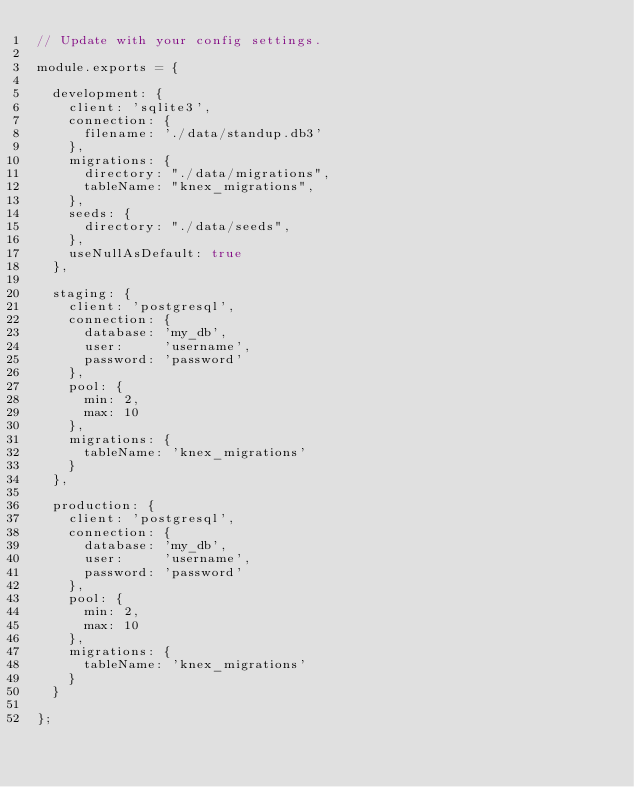Convert code to text. <code><loc_0><loc_0><loc_500><loc_500><_JavaScript_>// Update with your config settings.

module.exports = {

  development: {
    client: 'sqlite3',
    connection: {
      filename: './data/standup.db3'
    },
    migrations: {
      directory: "./data/migrations",
      tableName: "knex_migrations",
    },
    seeds: {
      directory: "./data/seeds",
    },
    useNullAsDefault: true
  },

  staging: {
    client: 'postgresql',
    connection: {
      database: 'my_db',
      user:     'username',
      password: 'password'
    },
    pool: {
      min: 2,
      max: 10
    },
    migrations: {
      tableName: 'knex_migrations'
    }
  },

  production: {
    client: 'postgresql',
    connection: {
      database: 'my_db',
      user:     'username',
      password: 'password'
    },
    pool: {
      min: 2,
      max: 10
    },
    migrations: {
      tableName: 'knex_migrations'
    }
  }

};
</code> 